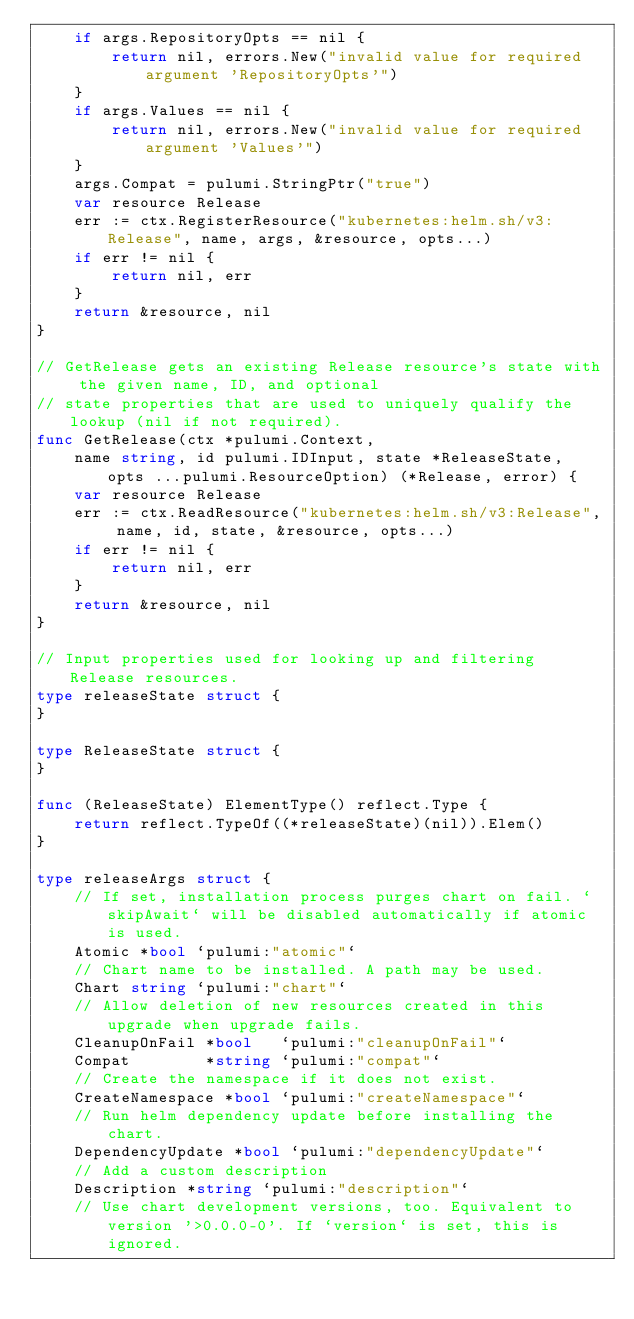Convert code to text. <code><loc_0><loc_0><loc_500><loc_500><_Go_>	if args.RepositoryOpts == nil {
		return nil, errors.New("invalid value for required argument 'RepositoryOpts'")
	}
	if args.Values == nil {
		return nil, errors.New("invalid value for required argument 'Values'")
	}
	args.Compat = pulumi.StringPtr("true")
	var resource Release
	err := ctx.RegisterResource("kubernetes:helm.sh/v3:Release", name, args, &resource, opts...)
	if err != nil {
		return nil, err
	}
	return &resource, nil
}

// GetRelease gets an existing Release resource's state with the given name, ID, and optional
// state properties that are used to uniquely qualify the lookup (nil if not required).
func GetRelease(ctx *pulumi.Context,
	name string, id pulumi.IDInput, state *ReleaseState, opts ...pulumi.ResourceOption) (*Release, error) {
	var resource Release
	err := ctx.ReadResource("kubernetes:helm.sh/v3:Release", name, id, state, &resource, opts...)
	if err != nil {
		return nil, err
	}
	return &resource, nil
}

// Input properties used for looking up and filtering Release resources.
type releaseState struct {
}

type ReleaseState struct {
}

func (ReleaseState) ElementType() reflect.Type {
	return reflect.TypeOf((*releaseState)(nil)).Elem()
}

type releaseArgs struct {
	// If set, installation process purges chart on fail. `skipAwait` will be disabled automatically if atomic is used.
	Atomic *bool `pulumi:"atomic"`
	// Chart name to be installed. A path may be used.
	Chart string `pulumi:"chart"`
	// Allow deletion of new resources created in this upgrade when upgrade fails.
	CleanupOnFail *bool   `pulumi:"cleanupOnFail"`
	Compat        *string `pulumi:"compat"`
	// Create the namespace if it does not exist.
	CreateNamespace *bool `pulumi:"createNamespace"`
	// Run helm dependency update before installing the chart.
	DependencyUpdate *bool `pulumi:"dependencyUpdate"`
	// Add a custom description
	Description *string `pulumi:"description"`
	// Use chart development versions, too. Equivalent to version '>0.0.0-0'. If `version` is set, this is ignored.</code> 